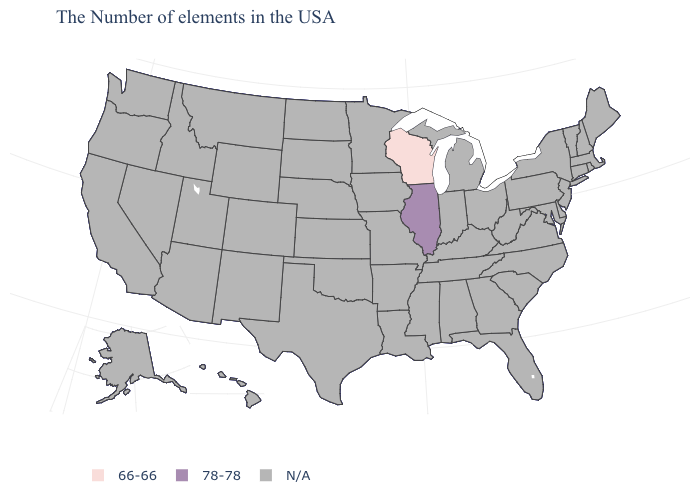What is the value of Ohio?
Short answer required. N/A. What is the highest value in the MidWest ?
Keep it brief. 78-78. What is the value of Vermont?
Concise answer only. N/A. What is the value of Kansas?
Short answer required. N/A. Name the states that have a value in the range 66-66?
Be succinct. Wisconsin. How many symbols are there in the legend?
Be succinct. 3. What is the value of Colorado?
Write a very short answer. N/A. What is the value of Massachusetts?
Be succinct. N/A. What is the highest value in the USA?
Write a very short answer. 78-78. Is the legend a continuous bar?
Be succinct. No. Name the states that have a value in the range 66-66?
Concise answer only. Wisconsin. 